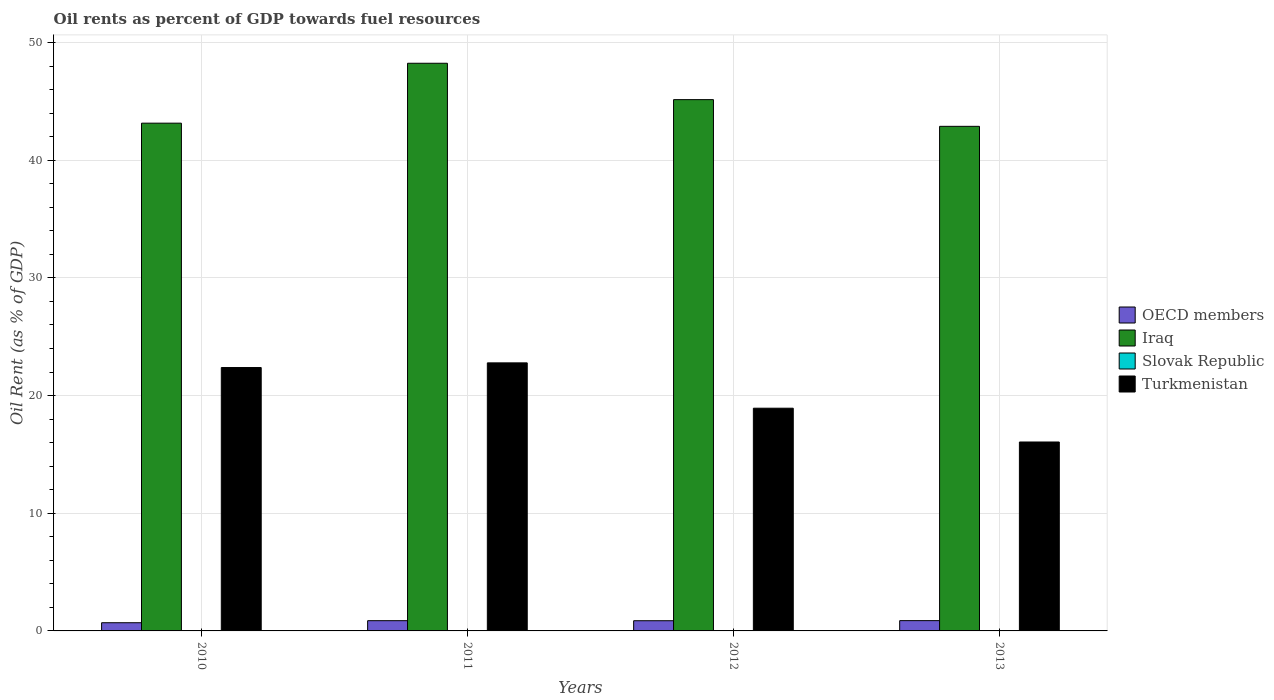How many groups of bars are there?
Provide a succinct answer. 4. How many bars are there on the 2nd tick from the left?
Offer a very short reply. 4. What is the oil rent in Iraq in 2013?
Your response must be concise. 42.88. Across all years, what is the maximum oil rent in OECD members?
Ensure brevity in your answer.  0.87. Across all years, what is the minimum oil rent in Iraq?
Ensure brevity in your answer.  42.88. In which year was the oil rent in Slovak Republic minimum?
Offer a very short reply. 2010. What is the total oil rent in Iraq in the graph?
Ensure brevity in your answer.  179.43. What is the difference between the oil rent in Slovak Republic in 2010 and that in 2012?
Keep it short and to the point. -0. What is the difference between the oil rent in Turkmenistan in 2010 and the oil rent in OECD members in 2013?
Offer a terse response. 21.51. What is the average oil rent in Slovak Republic per year?
Make the answer very short. 0.01. In the year 2010, what is the difference between the oil rent in OECD members and oil rent in Slovak Republic?
Make the answer very short. 0.69. In how many years, is the oil rent in OECD members greater than 46 %?
Provide a short and direct response. 0. What is the ratio of the oil rent in Turkmenistan in 2010 to that in 2011?
Your answer should be compact. 0.98. Is the oil rent in Iraq in 2011 less than that in 2013?
Provide a short and direct response. No. What is the difference between the highest and the second highest oil rent in OECD members?
Give a very brief answer. 0. What is the difference between the highest and the lowest oil rent in Slovak Republic?
Offer a very short reply. 0. What does the 4th bar from the left in 2013 represents?
Give a very brief answer. Turkmenistan. What does the 1st bar from the right in 2010 represents?
Give a very brief answer. Turkmenistan. How many bars are there?
Give a very brief answer. 16. Are all the bars in the graph horizontal?
Offer a very short reply. No. How many years are there in the graph?
Your answer should be compact. 4. What is the difference between two consecutive major ticks on the Y-axis?
Offer a terse response. 10. Are the values on the major ticks of Y-axis written in scientific E-notation?
Ensure brevity in your answer.  No. Does the graph contain any zero values?
Give a very brief answer. No. Does the graph contain grids?
Keep it short and to the point. Yes. How many legend labels are there?
Provide a short and direct response. 4. What is the title of the graph?
Make the answer very short. Oil rents as percent of GDP towards fuel resources. What is the label or title of the X-axis?
Your answer should be compact. Years. What is the label or title of the Y-axis?
Give a very brief answer. Oil Rent (as % of GDP). What is the Oil Rent (as % of GDP) of OECD members in 2010?
Offer a very short reply. 0.7. What is the Oil Rent (as % of GDP) of Iraq in 2010?
Ensure brevity in your answer.  43.15. What is the Oil Rent (as % of GDP) in Slovak Republic in 2010?
Your answer should be very brief. 0.01. What is the Oil Rent (as % of GDP) of Turkmenistan in 2010?
Your answer should be very brief. 22.38. What is the Oil Rent (as % of GDP) of OECD members in 2011?
Offer a very short reply. 0.87. What is the Oil Rent (as % of GDP) of Iraq in 2011?
Provide a short and direct response. 48.24. What is the Oil Rent (as % of GDP) in Slovak Republic in 2011?
Keep it short and to the point. 0.01. What is the Oil Rent (as % of GDP) in Turkmenistan in 2011?
Your answer should be compact. 22.78. What is the Oil Rent (as % of GDP) of OECD members in 2012?
Your answer should be compact. 0.87. What is the Oil Rent (as % of GDP) in Iraq in 2012?
Make the answer very short. 45.15. What is the Oil Rent (as % of GDP) of Slovak Republic in 2012?
Offer a terse response. 0.01. What is the Oil Rent (as % of GDP) of Turkmenistan in 2012?
Keep it short and to the point. 18.93. What is the Oil Rent (as % of GDP) in OECD members in 2013?
Your answer should be compact. 0.87. What is the Oil Rent (as % of GDP) in Iraq in 2013?
Provide a short and direct response. 42.88. What is the Oil Rent (as % of GDP) in Slovak Republic in 2013?
Your response must be concise. 0.01. What is the Oil Rent (as % of GDP) in Turkmenistan in 2013?
Give a very brief answer. 16.06. Across all years, what is the maximum Oil Rent (as % of GDP) in OECD members?
Keep it short and to the point. 0.87. Across all years, what is the maximum Oil Rent (as % of GDP) in Iraq?
Offer a terse response. 48.24. Across all years, what is the maximum Oil Rent (as % of GDP) in Slovak Republic?
Ensure brevity in your answer.  0.01. Across all years, what is the maximum Oil Rent (as % of GDP) in Turkmenistan?
Make the answer very short. 22.78. Across all years, what is the minimum Oil Rent (as % of GDP) of OECD members?
Give a very brief answer. 0.7. Across all years, what is the minimum Oil Rent (as % of GDP) of Iraq?
Your answer should be compact. 42.88. Across all years, what is the minimum Oil Rent (as % of GDP) of Slovak Republic?
Provide a succinct answer. 0.01. Across all years, what is the minimum Oil Rent (as % of GDP) in Turkmenistan?
Your answer should be very brief. 16.06. What is the total Oil Rent (as % of GDP) of OECD members in the graph?
Offer a terse response. 3.31. What is the total Oil Rent (as % of GDP) in Iraq in the graph?
Your answer should be compact. 179.43. What is the total Oil Rent (as % of GDP) in Slovak Republic in the graph?
Your response must be concise. 0.03. What is the total Oil Rent (as % of GDP) in Turkmenistan in the graph?
Ensure brevity in your answer.  80.15. What is the difference between the Oil Rent (as % of GDP) of OECD members in 2010 and that in 2011?
Your response must be concise. -0.17. What is the difference between the Oil Rent (as % of GDP) of Iraq in 2010 and that in 2011?
Your answer should be very brief. -5.09. What is the difference between the Oil Rent (as % of GDP) of Slovak Republic in 2010 and that in 2011?
Make the answer very short. -0. What is the difference between the Oil Rent (as % of GDP) of Turkmenistan in 2010 and that in 2011?
Your answer should be very brief. -0.4. What is the difference between the Oil Rent (as % of GDP) in OECD members in 2010 and that in 2012?
Offer a terse response. -0.17. What is the difference between the Oil Rent (as % of GDP) of Iraq in 2010 and that in 2012?
Your answer should be compact. -2. What is the difference between the Oil Rent (as % of GDP) in Slovak Republic in 2010 and that in 2012?
Your response must be concise. -0. What is the difference between the Oil Rent (as % of GDP) in Turkmenistan in 2010 and that in 2012?
Your response must be concise. 3.46. What is the difference between the Oil Rent (as % of GDP) in OECD members in 2010 and that in 2013?
Ensure brevity in your answer.  -0.18. What is the difference between the Oil Rent (as % of GDP) of Iraq in 2010 and that in 2013?
Provide a short and direct response. 0.27. What is the difference between the Oil Rent (as % of GDP) in Slovak Republic in 2010 and that in 2013?
Provide a short and direct response. -0. What is the difference between the Oil Rent (as % of GDP) of Turkmenistan in 2010 and that in 2013?
Provide a succinct answer. 6.33. What is the difference between the Oil Rent (as % of GDP) of OECD members in 2011 and that in 2012?
Offer a terse response. 0. What is the difference between the Oil Rent (as % of GDP) of Iraq in 2011 and that in 2012?
Your answer should be compact. 3.09. What is the difference between the Oil Rent (as % of GDP) in Slovak Republic in 2011 and that in 2012?
Ensure brevity in your answer.  0. What is the difference between the Oil Rent (as % of GDP) in Turkmenistan in 2011 and that in 2012?
Your response must be concise. 3.85. What is the difference between the Oil Rent (as % of GDP) of OECD members in 2011 and that in 2013?
Give a very brief answer. -0. What is the difference between the Oil Rent (as % of GDP) in Iraq in 2011 and that in 2013?
Your answer should be very brief. 5.36. What is the difference between the Oil Rent (as % of GDP) of Slovak Republic in 2011 and that in 2013?
Give a very brief answer. 0. What is the difference between the Oil Rent (as % of GDP) in Turkmenistan in 2011 and that in 2013?
Offer a terse response. 6.72. What is the difference between the Oil Rent (as % of GDP) of OECD members in 2012 and that in 2013?
Ensure brevity in your answer.  -0.01. What is the difference between the Oil Rent (as % of GDP) in Iraq in 2012 and that in 2013?
Your answer should be very brief. 2.27. What is the difference between the Oil Rent (as % of GDP) in Slovak Republic in 2012 and that in 2013?
Offer a terse response. 0. What is the difference between the Oil Rent (as % of GDP) in Turkmenistan in 2012 and that in 2013?
Your answer should be very brief. 2.87. What is the difference between the Oil Rent (as % of GDP) of OECD members in 2010 and the Oil Rent (as % of GDP) of Iraq in 2011?
Your answer should be compact. -47.55. What is the difference between the Oil Rent (as % of GDP) of OECD members in 2010 and the Oil Rent (as % of GDP) of Slovak Republic in 2011?
Provide a short and direct response. 0.69. What is the difference between the Oil Rent (as % of GDP) in OECD members in 2010 and the Oil Rent (as % of GDP) in Turkmenistan in 2011?
Make the answer very short. -22.08. What is the difference between the Oil Rent (as % of GDP) in Iraq in 2010 and the Oil Rent (as % of GDP) in Slovak Republic in 2011?
Provide a succinct answer. 43.14. What is the difference between the Oil Rent (as % of GDP) in Iraq in 2010 and the Oil Rent (as % of GDP) in Turkmenistan in 2011?
Your answer should be very brief. 20.37. What is the difference between the Oil Rent (as % of GDP) of Slovak Republic in 2010 and the Oil Rent (as % of GDP) of Turkmenistan in 2011?
Your response must be concise. -22.77. What is the difference between the Oil Rent (as % of GDP) of OECD members in 2010 and the Oil Rent (as % of GDP) of Iraq in 2012?
Give a very brief answer. -44.46. What is the difference between the Oil Rent (as % of GDP) in OECD members in 2010 and the Oil Rent (as % of GDP) in Slovak Republic in 2012?
Ensure brevity in your answer.  0.69. What is the difference between the Oil Rent (as % of GDP) in OECD members in 2010 and the Oil Rent (as % of GDP) in Turkmenistan in 2012?
Offer a terse response. -18.23. What is the difference between the Oil Rent (as % of GDP) in Iraq in 2010 and the Oil Rent (as % of GDP) in Slovak Republic in 2012?
Make the answer very short. 43.15. What is the difference between the Oil Rent (as % of GDP) in Iraq in 2010 and the Oil Rent (as % of GDP) in Turkmenistan in 2012?
Provide a succinct answer. 24.23. What is the difference between the Oil Rent (as % of GDP) in Slovak Republic in 2010 and the Oil Rent (as % of GDP) in Turkmenistan in 2012?
Offer a terse response. -18.92. What is the difference between the Oil Rent (as % of GDP) in OECD members in 2010 and the Oil Rent (as % of GDP) in Iraq in 2013?
Provide a short and direct response. -42.19. What is the difference between the Oil Rent (as % of GDP) of OECD members in 2010 and the Oil Rent (as % of GDP) of Slovak Republic in 2013?
Ensure brevity in your answer.  0.69. What is the difference between the Oil Rent (as % of GDP) of OECD members in 2010 and the Oil Rent (as % of GDP) of Turkmenistan in 2013?
Your response must be concise. -15.36. What is the difference between the Oil Rent (as % of GDP) of Iraq in 2010 and the Oil Rent (as % of GDP) of Slovak Republic in 2013?
Your answer should be very brief. 43.15. What is the difference between the Oil Rent (as % of GDP) of Iraq in 2010 and the Oil Rent (as % of GDP) of Turkmenistan in 2013?
Offer a terse response. 27.1. What is the difference between the Oil Rent (as % of GDP) in Slovak Republic in 2010 and the Oil Rent (as % of GDP) in Turkmenistan in 2013?
Provide a short and direct response. -16.05. What is the difference between the Oil Rent (as % of GDP) of OECD members in 2011 and the Oil Rent (as % of GDP) of Iraq in 2012?
Provide a succinct answer. -44.28. What is the difference between the Oil Rent (as % of GDP) in OECD members in 2011 and the Oil Rent (as % of GDP) in Slovak Republic in 2012?
Your answer should be compact. 0.86. What is the difference between the Oil Rent (as % of GDP) in OECD members in 2011 and the Oil Rent (as % of GDP) in Turkmenistan in 2012?
Offer a terse response. -18.06. What is the difference between the Oil Rent (as % of GDP) of Iraq in 2011 and the Oil Rent (as % of GDP) of Slovak Republic in 2012?
Provide a short and direct response. 48.24. What is the difference between the Oil Rent (as % of GDP) in Iraq in 2011 and the Oil Rent (as % of GDP) in Turkmenistan in 2012?
Your answer should be very brief. 29.32. What is the difference between the Oil Rent (as % of GDP) of Slovak Republic in 2011 and the Oil Rent (as % of GDP) of Turkmenistan in 2012?
Offer a terse response. -18.92. What is the difference between the Oil Rent (as % of GDP) of OECD members in 2011 and the Oil Rent (as % of GDP) of Iraq in 2013?
Keep it short and to the point. -42.01. What is the difference between the Oil Rent (as % of GDP) of OECD members in 2011 and the Oil Rent (as % of GDP) of Slovak Republic in 2013?
Provide a succinct answer. 0.86. What is the difference between the Oil Rent (as % of GDP) in OECD members in 2011 and the Oil Rent (as % of GDP) in Turkmenistan in 2013?
Your answer should be very brief. -15.19. What is the difference between the Oil Rent (as % of GDP) of Iraq in 2011 and the Oil Rent (as % of GDP) of Slovak Republic in 2013?
Make the answer very short. 48.24. What is the difference between the Oil Rent (as % of GDP) in Iraq in 2011 and the Oil Rent (as % of GDP) in Turkmenistan in 2013?
Your answer should be very brief. 32.19. What is the difference between the Oil Rent (as % of GDP) of Slovak Republic in 2011 and the Oil Rent (as % of GDP) of Turkmenistan in 2013?
Keep it short and to the point. -16.05. What is the difference between the Oil Rent (as % of GDP) of OECD members in 2012 and the Oil Rent (as % of GDP) of Iraq in 2013?
Provide a short and direct response. -42.02. What is the difference between the Oil Rent (as % of GDP) of OECD members in 2012 and the Oil Rent (as % of GDP) of Slovak Republic in 2013?
Keep it short and to the point. 0.86. What is the difference between the Oil Rent (as % of GDP) of OECD members in 2012 and the Oil Rent (as % of GDP) of Turkmenistan in 2013?
Offer a very short reply. -15.19. What is the difference between the Oil Rent (as % of GDP) in Iraq in 2012 and the Oil Rent (as % of GDP) in Slovak Republic in 2013?
Give a very brief answer. 45.14. What is the difference between the Oil Rent (as % of GDP) in Iraq in 2012 and the Oil Rent (as % of GDP) in Turkmenistan in 2013?
Provide a succinct answer. 29.1. What is the difference between the Oil Rent (as % of GDP) of Slovak Republic in 2012 and the Oil Rent (as % of GDP) of Turkmenistan in 2013?
Your answer should be compact. -16.05. What is the average Oil Rent (as % of GDP) of OECD members per year?
Provide a succinct answer. 0.83. What is the average Oil Rent (as % of GDP) of Iraq per year?
Make the answer very short. 44.86. What is the average Oil Rent (as % of GDP) of Slovak Republic per year?
Your response must be concise. 0.01. What is the average Oil Rent (as % of GDP) in Turkmenistan per year?
Make the answer very short. 20.04. In the year 2010, what is the difference between the Oil Rent (as % of GDP) of OECD members and Oil Rent (as % of GDP) of Iraq?
Keep it short and to the point. -42.46. In the year 2010, what is the difference between the Oil Rent (as % of GDP) of OECD members and Oil Rent (as % of GDP) of Slovak Republic?
Give a very brief answer. 0.69. In the year 2010, what is the difference between the Oil Rent (as % of GDP) in OECD members and Oil Rent (as % of GDP) in Turkmenistan?
Your answer should be very brief. -21.69. In the year 2010, what is the difference between the Oil Rent (as % of GDP) in Iraq and Oil Rent (as % of GDP) in Slovak Republic?
Provide a short and direct response. 43.15. In the year 2010, what is the difference between the Oil Rent (as % of GDP) in Iraq and Oil Rent (as % of GDP) in Turkmenistan?
Give a very brief answer. 20.77. In the year 2010, what is the difference between the Oil Rent (as % of GDP) in Slovak Republic and Oil Rent (as % of GDP) in Turkmenistan?
Offer a very short reply. -22.38. In the year 2011, what is the difference between the Oil Rent (as % of GDP) of OECD members and Oil Rent (as % of GDP) of Iraq?
Give a very brief answer. -47.37. In the year 2011, what is the difference between the Oil Rent (as % of GDP) of OECD members and Oil Rent (as % of GDP) of Slovak Republic?
Give a very brief answer. 0.86. In the year 2011, what is the difference between the Oil Rent (as % of GDP) in OECD members and Oil Rent (as % of GDP) in Turkmenistan?
Your response must be concise. -21.91. In the year 2011, what is the difference between the Oil Rent (as % of GDP) of Iraq and Oil Rent (as % of GDP) of Slovak Republic?
Give a very brief answer. 48.23. In the year 2011, what is the difference between the Oil Rent (as % of GDP) in Iraq and Oil Rent (as % of GDP) in Turkmenistan?
Your answer should be compact. 25.46. In the year 2011, what is the difference between the Oil Rent (as % of GDP) in Slovak Republic and Oil Rent (as % of GDP) in Turkmenistan?
Your answer should be compact. -22.77. In the year 2012, what is the difference between the Oil Rent (as % of GDP) of OECD members and Oil Rent (as % of GDP) of Iraq?
Offer a terse response. -44.29. In the year 2012, what is the difference between the Oil Rent (as % of GDP) of OECD members and Oil Rent (as % of GDP) of Slovak Republic?
Your response must be concise. 0.86. In the year 2012, what is the difference between the Oil Rent (as % of GDP) in OECD members and Oil Rent (as % of GDP) in Turkmenistan?
Your answer should be very brief. -18.06. In the year 2012, what is the difference between the Oil Rent (as % of GDP) of Iraq and Oil Rent (as % of GDP) of Slovak Republic?
Your answer should be compact. 45.14. In the year 2012, what is the difference between the Oil Rent (as % of GDP) in Iraq and Oil Rent (as % of GDP) in Turkmenistan?
Your response must be concise. 26.22. In the year 2012, what is the difference between the Oil Rent (as % of GDP) of Slovak Republic and Oil Rent (as % of GDP) of Turkmenistan?
Offer a terse response. -18.92. In the year 2013, what is the difference between the Oil Rent (as % of GDP) in OECD members and Oil Rent (as % of GDP) in Iraq?
Make the answer very short. -42.01. In the year 2013, what is the difference between the Oil Rent (as % of GDP) of OECD members and Oil Rent (as % of GDP) of Slovak Republic?
Give a very brief answer. 0.87. In the year 2013, what is the difference between the Oil Rent (as % of GDP) of OECD members and Oil Rent (as % of GDP) of Turkmenistan?
Give a very brief answer. -15.18. In the year 2013, what is the difference between the Oil Rent (as % of GDP) of Iraq and Oil Rent (as % of GDP) of Slovak Republic?
Offer a very short reply. 42.88. In the year 2013, what is the difference between the Oil Rent (as % of GDP) in Iraq and Oil Rent (as % of GDP) in Turkmenistan?
Provide a succinct answer. 26.83. In the year 2013, what is the difference between the Oil Rent (as % of GDP) in Slovak Republic and Oil Rent (as % of GDP) in Turkmenistan?
Your answer should be very brief. -16.05. What is the ratio of the Oil Rent (as % of GDP) in OECD members in 2010 to that in 2011?
Provide a short and direct response. 0.8. What is the ratio of the Oil Rent (as % of GDP) in Iraq in 2010 to that in 2011?
Provide a succinct answer. 0.89. What is the ratio of the Oil Rent (as % of GDP) of Slovak Republic in 2010 to that in 2011?
Keep it short and to the point. 0.71. What is the ratio of the Oil Rent (as % of GDP) in Turkmenistan in 2010 to that in 2011?
Provide a short and direct response. 0.98. What is the ratio of the Oil Rent (as % of GDP) of OECD members in 2010 to that in 2012?
Offer a terse response. 0.8. What is the ratio of the Oil Rent (as % of GDP) in Iraq in 2010 to that in 2012?
Keep it short and to the point. 0.96. What is the ratio of the Oil Rent (as % of GDP) in Slovak Republic in 2010 to that in 2012?
Offer a very short reply. 0.94. What is the ratio of the Oil Rent (as % of GDP) of Turkmenistan in 2010 to that in 2012?
Offer a terse response. 1.18. What is the ratio of the Oil Rent (as % of GDP) in OECD members in 2010 to that in 2013?
Your response must be concise. 0.8. What is the ratio of the Oil Rent (as % of GDP) in Slovak Republic in 2010 to that in 2013?
Your answer should be compact. 0.95. What is the ratio of the Oil Rent (as % of GDP) of Turkmenistan in 2010 to that in 2013?
Your answer should be compact. 1.39. What is the ratio of the Oil Rent (as % of GDP) of Iraq in 2011 to that in 2012?
Provide a succinct answer. 1.07. What is the ratio of the Oil Rent (as % of GDP) of Slovak Republic in 2011 to that in 2012?
Your answer should be very brief. 1.33. What is the ratio of the Oil Rent (as % of GDP) in Turkmenistan in 2011 to that in 2012?
Offer a terse response. 1.2. What is the ratio of the Oil Rent (as % of GDP) in Iraq in 2011 to that in 2013?
Ensure brevity in your answer.  1.12. What is the ratio of the Oil Rent (as % of GDP) of Slovak Republic in 2011 to that in 2013?
Give a very brief answer. 1.35. What is the ratio of the Oil Rent (as % of GDP) of Turkmenistan in 2011 to that in 2013?
Your response must be concise. 1.42. What is the ratio of the Oil Rent (as % of GDP) in OECD members in 2012 to that in 2013?
Offer a terse response. 0.99. What is the ratio of the Oil Rent (as % of GDP) of Iraq in 2012 to that in 2013?
Offer a terse response. 1.05. What is the ratio of the Oil Rent (as % of GDP) of Slovak Republic in 2012 to that in 2013?
Your answer should be very brief. 1.01. What is the ratio of the Oil Rent (as % of GDP) in Turkmenistan in 2012 to that in 2013?
Your answer should be very brief. 1.18. What is the difference between the highest and the second highest Oil Rent (as % of GDP) of OECD members?
Offer a very short reply. 0. What is the difference between the highest and the second highest Oil Rent (as % of GDP) in Iraq?
Provide a short and direct response. 3.09. What is the difference between the highest and the second highest Oil Rent (as % of GDP) in Slovak Republic?
Give a very brief answer. 0. What is the difference between the highest and the second highest Oil Rent (as % of GDP) in Turkmenistan?
Provide a short and direct response. 0.4. What is the difference between the highest and the lowest Oil Rent (as % of GDP) of OECD members?
Your answer should be compact. 0.18. What is the difference between the highest and the lowest Oil Rent (as % of GDP) of Iraq?
Provide a succinct answer. 5.36. What is the difference between the highest and the lowest Oil Rent (as % of GDP) in Slovak Republic?
Your answer should be very brief. 0. What is the difference between the highest and the lowest Oil Rent (as % of GDP) of Turkmenistan?
Make the answer very short. 6.72. 